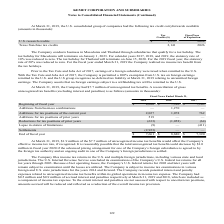From Kemet Corporation's financial document, Which years does the table provide information for the gross unrecognized tax benefits for the company? The document contains multiple relevant values: 2019, 2018, 2017. From the document: "2019 2018 2017 2019 2018 2017 2019 2018 2017..." Also, What was the amount of gross unrecognized tax benefits at the beginning of fiscal year in 2019? According to the financial document, 8,680 (in thousands). The relevant text states: "Beginning of fiscal year $ 8,680 $ 7,390 $ 7,103..." Also, What was the Lapse in statute of limitations in 2017? According to the financial document, (411) (in thousands). The relevant text states: "Lapse in statute of limitations (9) — (411)..." Also, can you calculate: What was the change in the Additions for tax positions of the current year between 2018 and 2019? Based on the calculation: 2,027-1,078, the result is 949 (in thousands). This is based on the information: "tions for tax positions of the current year 2,027 1,078 762 Additions for tax positions of the current year 2,027 1,078 762..." The key data points involved are: 1,078, 2,027. Also, can you calculate: What was the change in the balance at the Beginning of fiscal year between 2017 and 2019? Based on the calculation: 8,680-7,103, the result is 1577 (in thousands). This is based on the information: "Beginning of fiscal year $ 8,680 $ 7,390 $ 7,103 Beginning of fiscal year $ 8,680 $ 7,390 $ 7,103..." The key data points involved are: 7,103, 8,680. Also, can you calculate: What was the percentage change in the end of fiscal year balance between 2017 and 2018? To answer this question, I need to perform calculations using the financial data. The calculation is: (8,680-7,390)/7,390, which equals 17.46 (percentage). This is based on the information: "Beginning of fiscal year $ 8,680 $ 7,390 $ 7,103 Beginning of fiscal year $ 8,680 $ 7,390 $ 7,103..." The key data points involved are: 7,390, 8,680. 